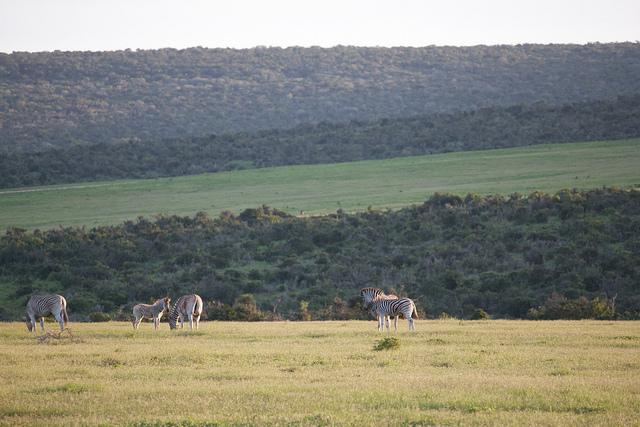How many zebras are sitting atop of the grassy field?

Choices:
A) one
B) four
C) three
D) two four 